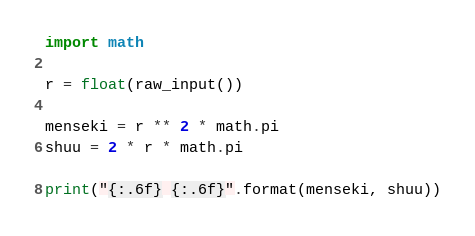<code> <loc_0><loc_0><loc_500><loc_500><_Python_>import math

r = float(raw_input())

menseki = r ** 2 * math.pi
shuu = 2 * r * math.pi

print("{:.6f} {:.6f}".format(menseki, shuu))</code> 